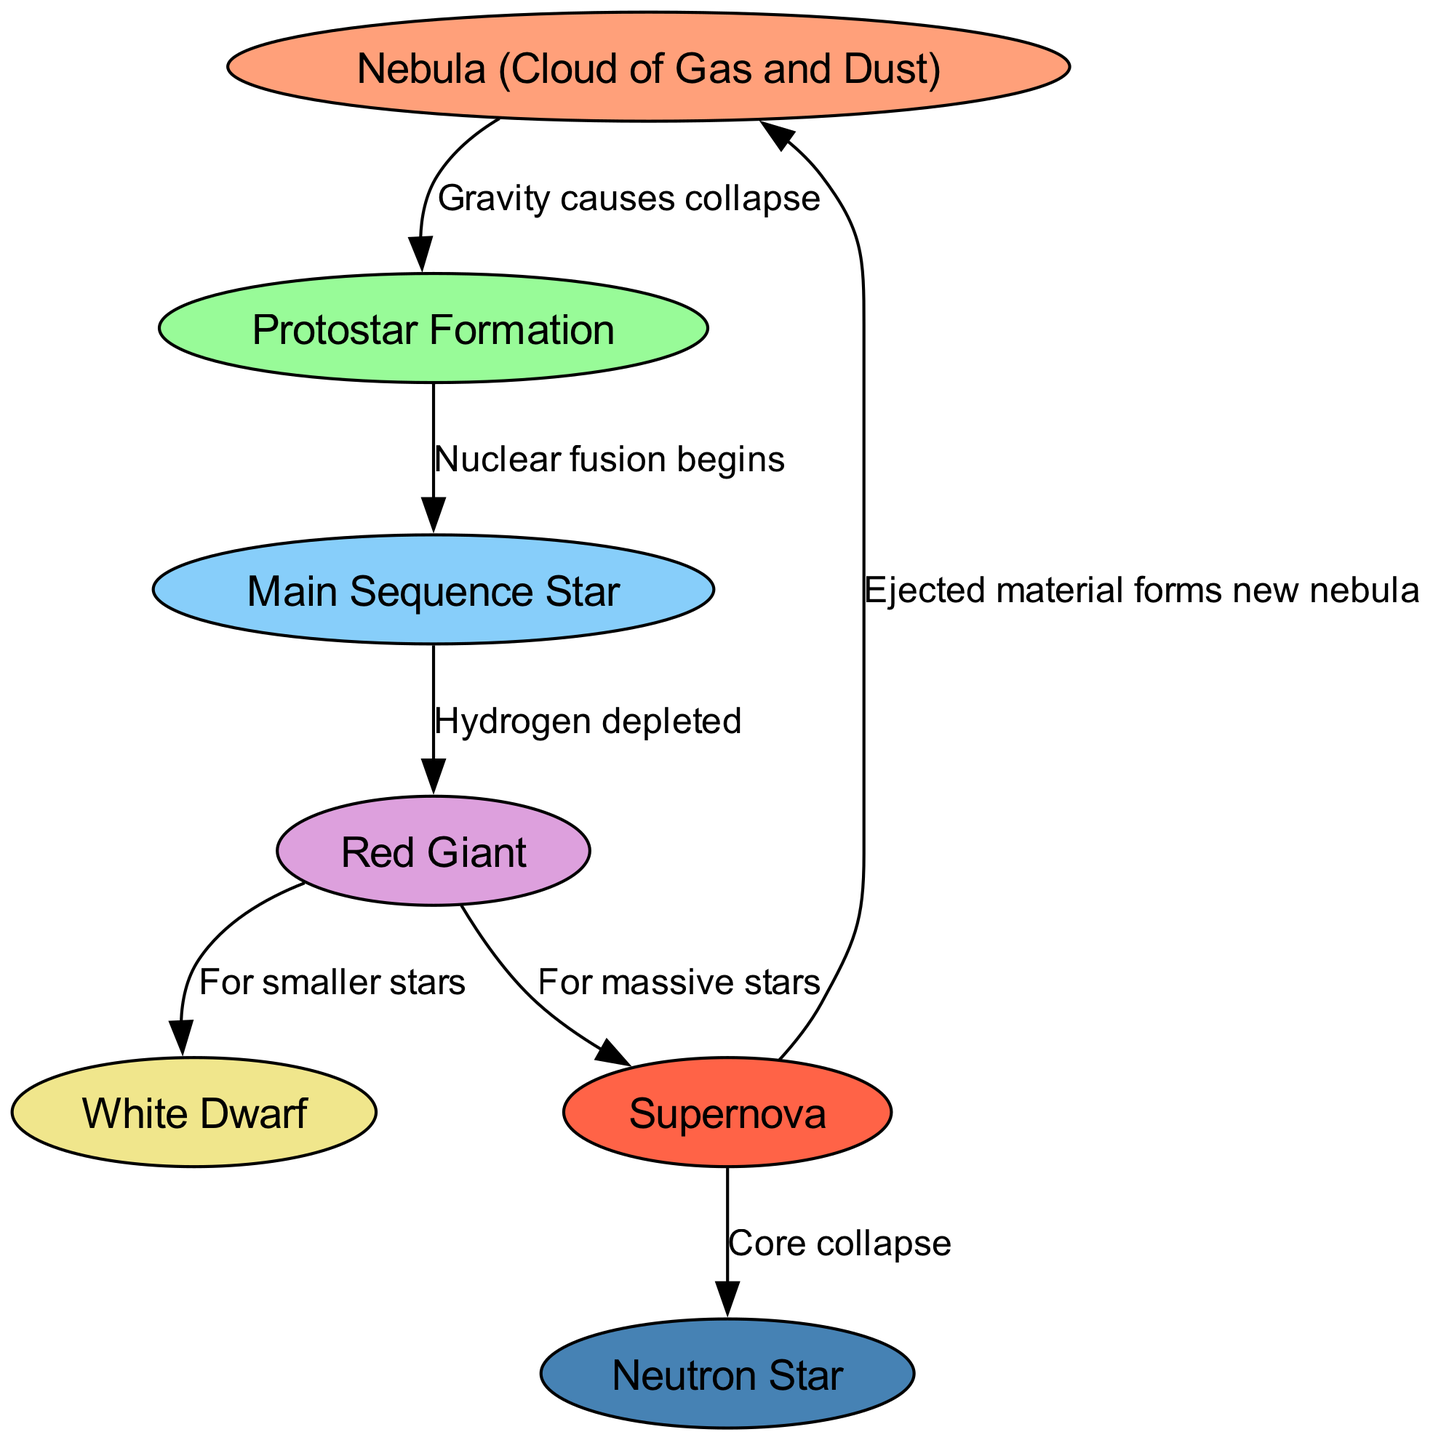What is the starting point of the star lifecycle? The diagram shows that the lifecycle begins with the node labeled "Nebula (Cloud of Gas and Dust)." This is the first node in the diagram, indicating the initial stage of a star's formation.
Answer: Nebula (Cloud of Gas and Dust) How many nodes are there in the diagram? By counting the node entries in the data, there are seven unique nodes described, which represent different stages of a star's lifecycle.
Answer: 7 What happens after protostar formation? According to the diagram, after the node "Protostar Formation," the next stage is marked by the transition to "Main Sequence Star," as indicated by the directed edge connecting these nodes.
Answer: Main Sequence Star What is the result of a supernova for massive stars? The diagram specifically indicates that for massive stars, the stage that follows a supernova is not indicated by a separate node but leads to the event itself because the "Supernova" node has two outgoing edges: one leading to "Neutron Star" and another returning to "Nebula." Thus, the main result of a supernova for massive stars is leading to "Neutron Star."
Answer: Neutron Star What do you call the process that occurs to transition from a red giant to a white dwarf? The directed edge from "Red Giant" to "White Dwarf" is labeled "For smaller stars," indicating the specific transition process relevant to smaller stars in the lifecycle.
Answer: For smaller stars What role does gravity play in nebula formation? The diagram explicitly states that gravity causes the collapse of the nebula, leading to the formation of a protostar. This relationship is depicted in the edge that connects the "Nebula" node to the "Protostar Formation" node with this labeled description.
Answer: Gravity causes collapse What forms after the core collapse during a supernova? The diagram shows an edge from "Supernova" to "Neutron Star" labeled "Core collapse," indicating that a neutron star forms as a direct result of the core collapse associated with a supernova event.
Answer: Neutron Star What is the relationship between red giant and supernova? The diagram depicts that a red giant can lead to two outcomes: for smaller stars, it transforms into a white dwarf, while for massive stars, it results in a supernova, indicating a bifurcation in the lifecycle based on the size of the star.
Answer: Red Giant leads to White Dwarf or Supernova 